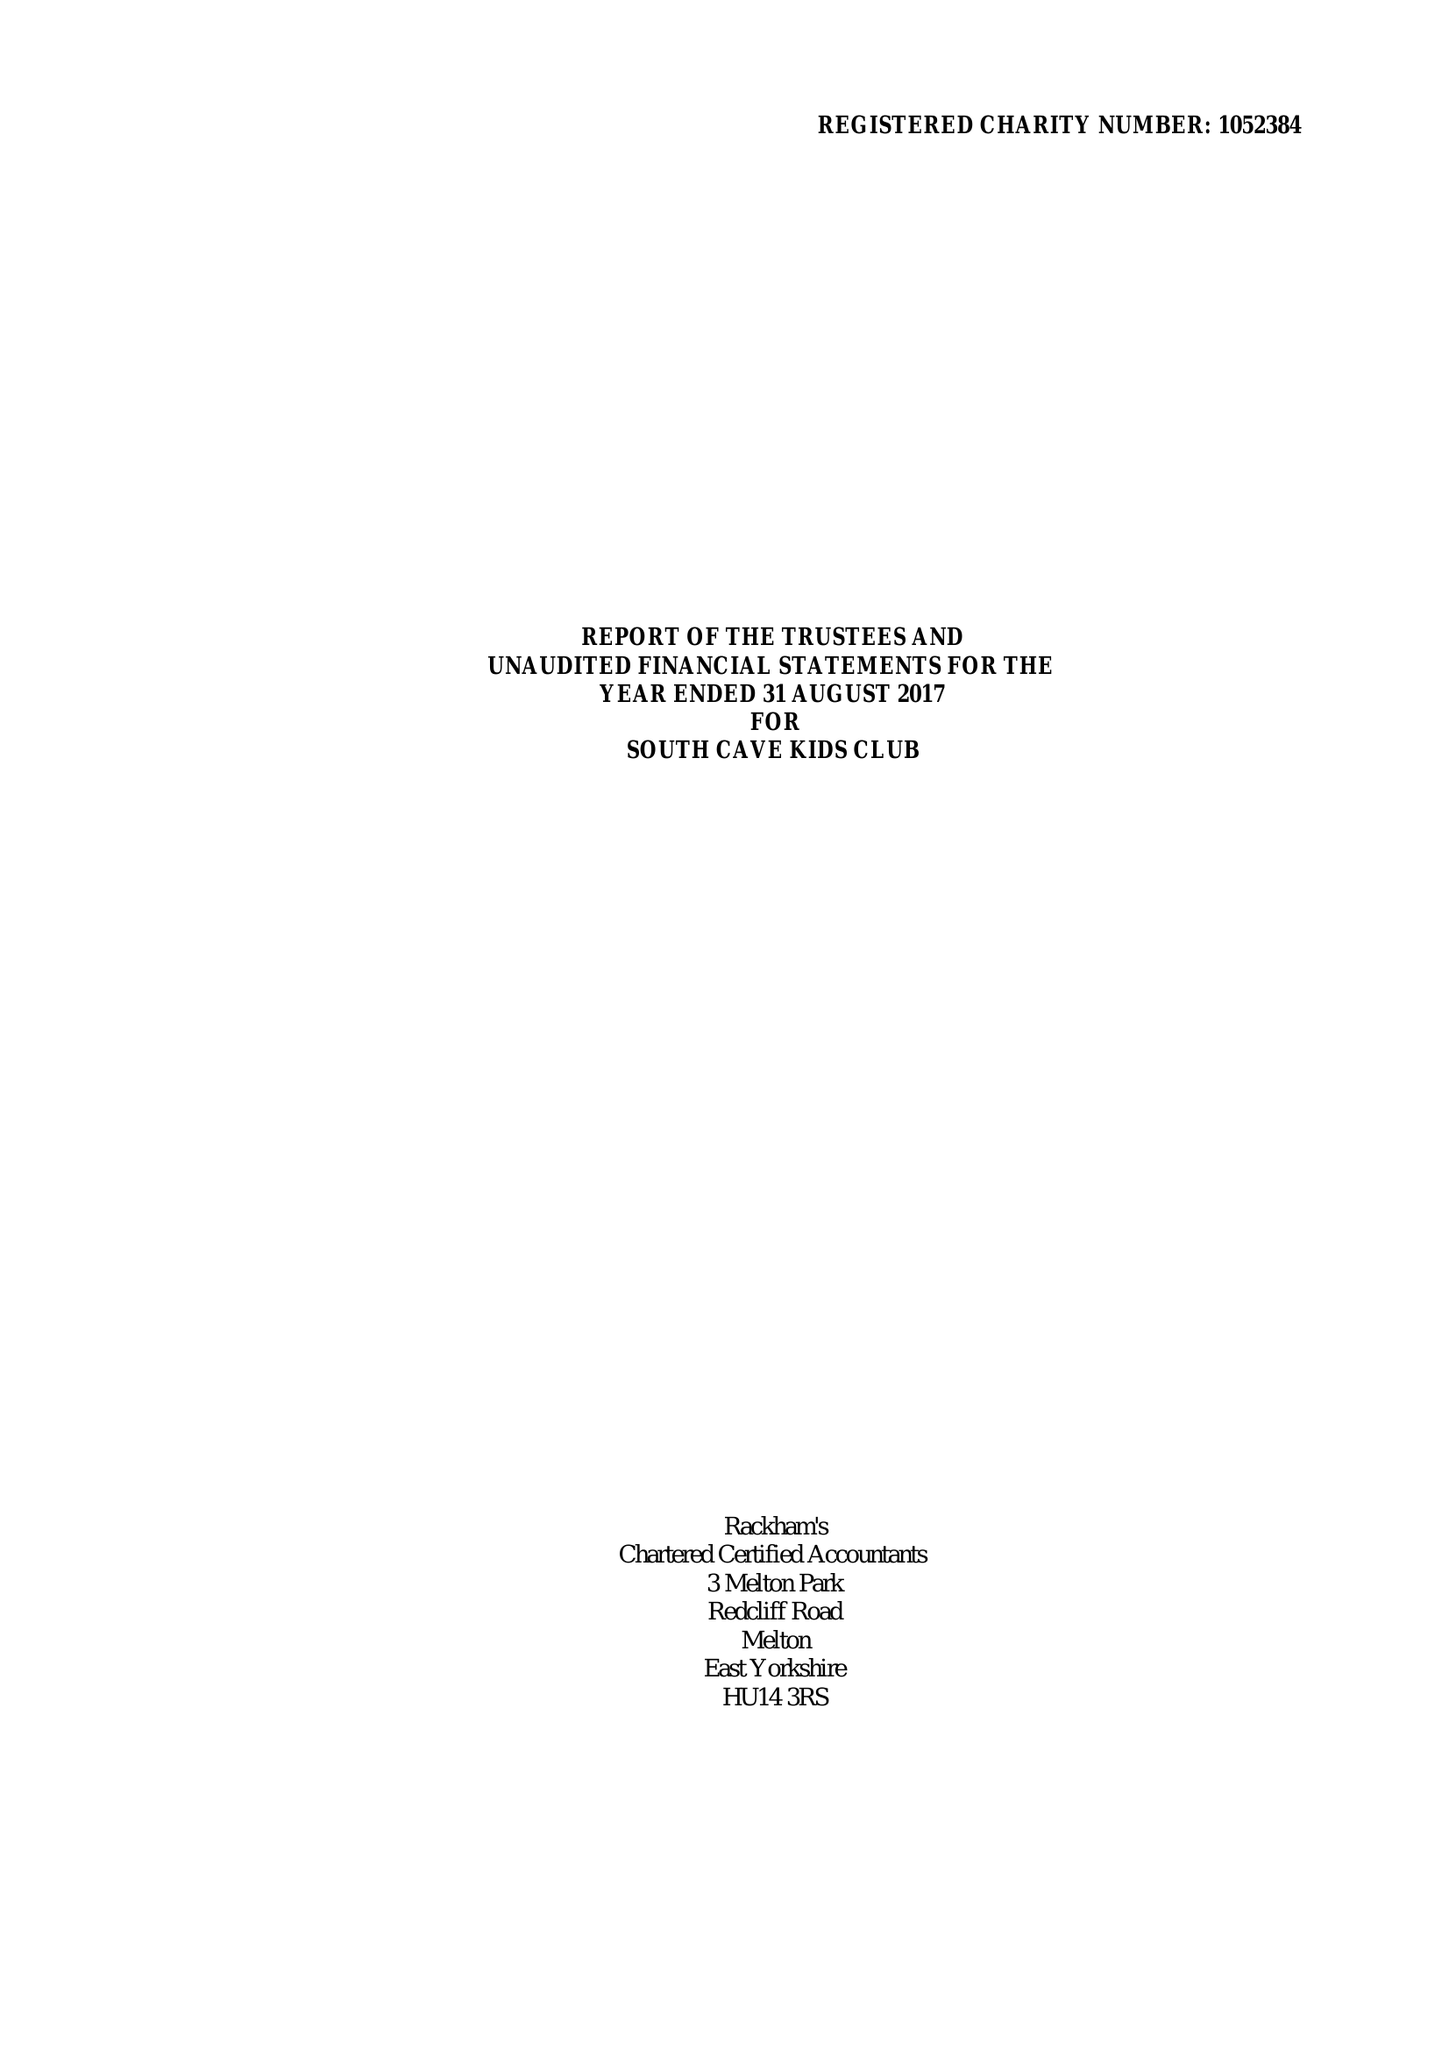What is the value for the income_annually_in_british_pounds?
Answer the question using a single word or phrase. 154200.00 